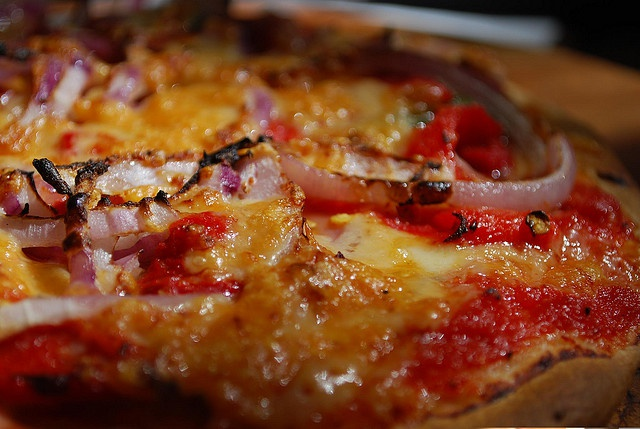Describe the objects in this image and their specific colors. I can see a pizza in maroon, brown, and black tones in this image. 